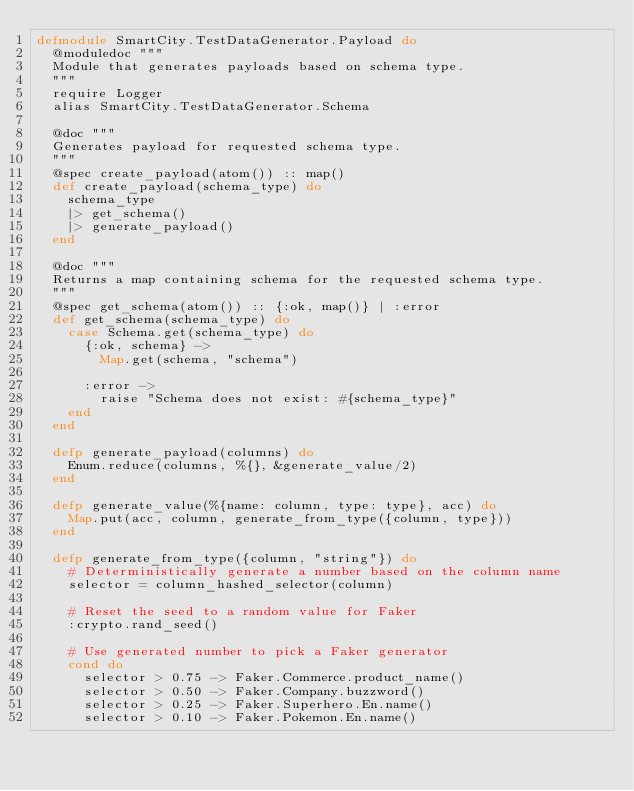Convert code to text. <code><loc_0><loc_0><loc_500><loc_500><_Elixir_>defmodule SmartCity.TestDataGenerator.Payload do
  @moduledoc """
  Module that generates payloads based on schema type.
  """
  require Logger
  alias SmartCity.TestDataGenerator.Schema

  @doc """
  Generates payload for requested schema type.
  """
  @spec create_payload(atom()) :: map()
  def create_payload(schema_type) do
    schema_type
    |> get_schema()
    |> generate_payload()
  end

  @doc """
  Returns a map containing schema for the requested schema type.
  """
  @spec get_schema(atom()) :: {:ok, map()} | :error
  def get_schema(schema_type) do
    case Schema.get(schema_type) do
      {:ok, schema} ->
        Map.get(schema, "schema")

      :error ->
        raise "Schema does not exist: #{schema_type}"
    end
  end

  defp generate_payload(columns) do
    Enum.reduce(columns, %{}, &generate_value/2)
  end

  defp generate_value(%{name: column, type: type}, acc) do
    Map.put(acc, column, generate_from_type({column, type}))
  end

  defp generate_from_type({column, "string"}) do
    # Deterministically generate a number based on the column name
    selector = column_hashed_selector(column)

    # Reset the seed to a random value for Faker
    :crypto.rand_seed()

    # Use generated number to pick a Faker generator
    cond do
      selector > 0.75 -> Faker.Commerce.product_name()
      selector > 0.50 -> Faker.Company.buzzword()
      selector > 0.25 -> Faker.Superhero.En.name()
      selector > 0.10 -> Faker.Pokemon.En.name()</code> 